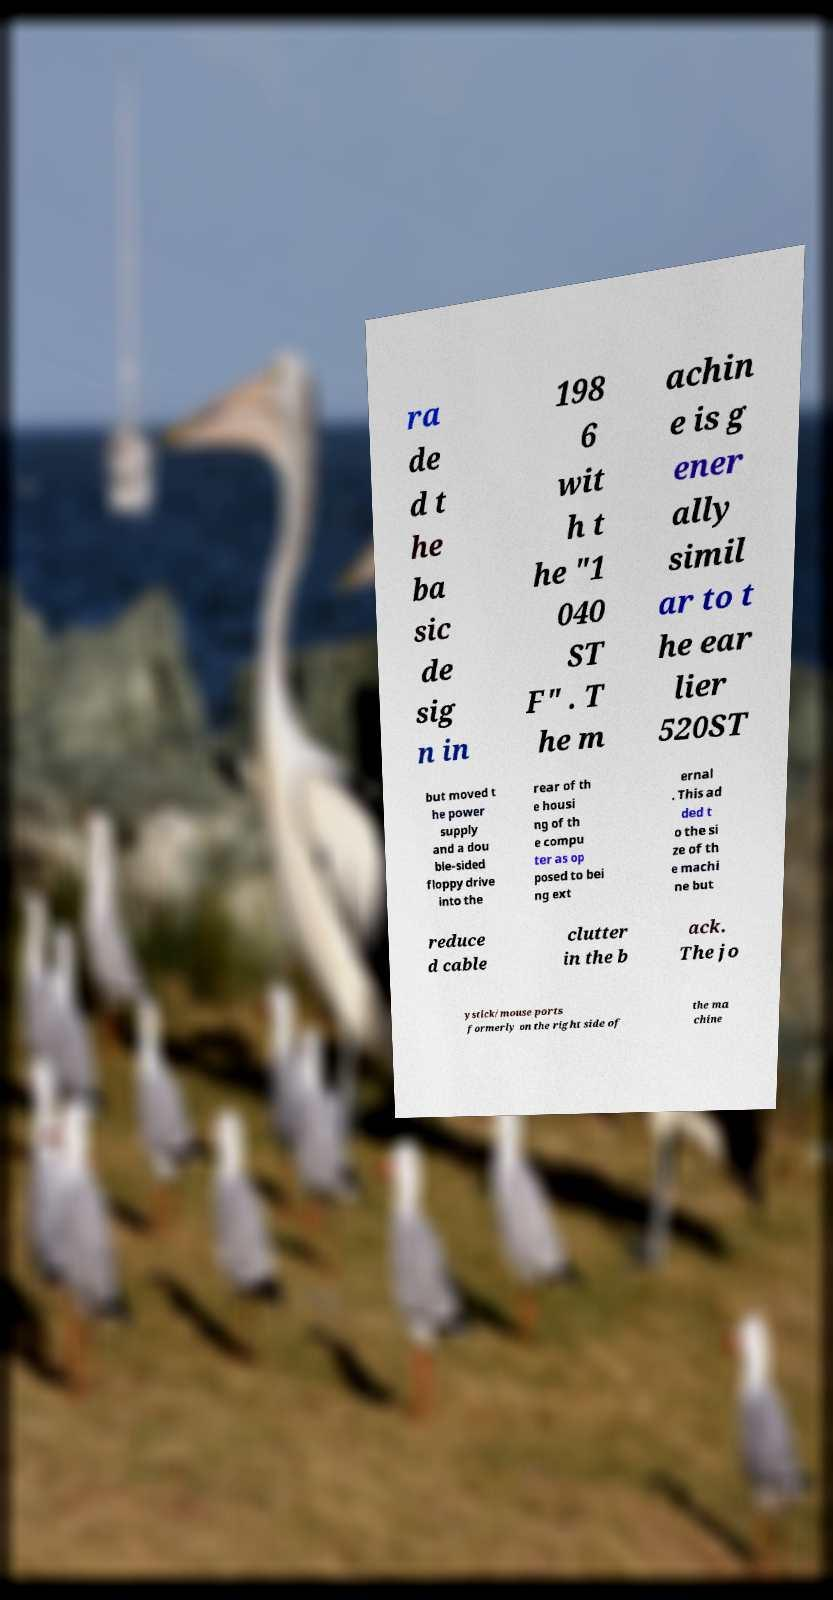Could you extract and type out the text from this image? ra de d t he ba sic de sig n in 198 6 wit h t he "1 040 ST F" . T he m achin e is g ener ally simil ar to t he ear lier 520ST but moved t he power supply and a dou ble-sided floppy drive into the rear of th e housi ng of th e compu ter as op posed to bei ng ext ernal . This ad ded t o the si ze of th e machi ne but reduce d cable clutter in the b ack. The jo ystick/mouse ports formerly on the right side of the ma chine 